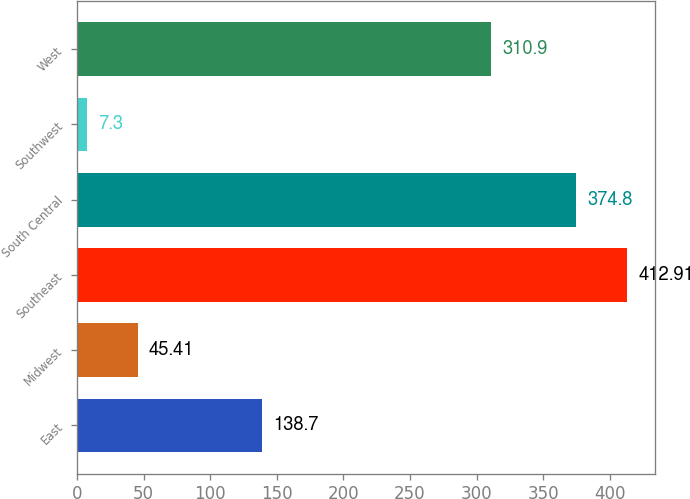<chart> <loc_0><loc_0><loc_500><loc_500><bar_chart><fcel>East<fcel>Midwest<fcel>Southeast<fcel>South Central<fcel>Southwest<fcel>West<nl><fcel>138.7<fcel>45.41<fcel>412.91<fcel>374.8<fcel>7.3<fcel>310.9<nl></chart> 